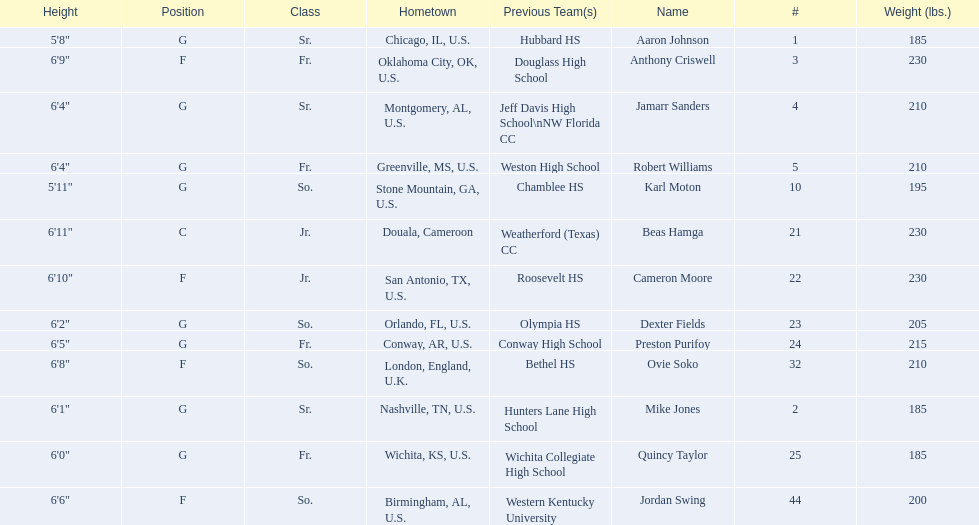How many total forwards are on the team? 4. 